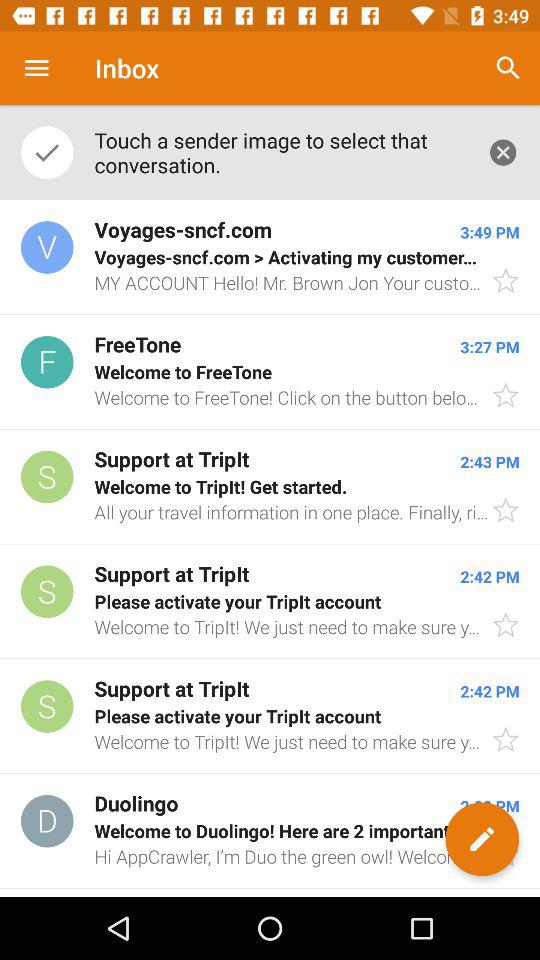At what time does the mail arrive from "Support at Triplt" to activate the account? The time is 2:42 PM. 